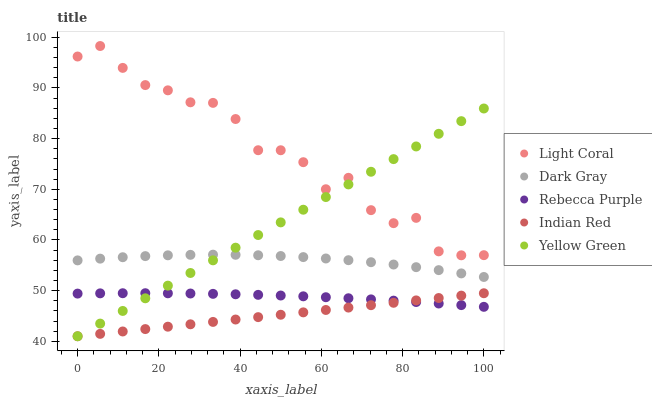Does Indian Red have the minimum area under the curve?
Answer yes or no. Yes. Does Light Coral have the maximum area under the curve?
Answer yes or no. Yes. Does Dark Gray have the minimum area under the curve?
Answer yes or no. No. Does Dark Gray have the maximum area under the curve?
Answer yes or no. No. Is Yellow Green the smoothest?
Answer yes or no. Yes. Is Light Coral the roughest?
Answer yes or no. Yes. Is Dark Gray the smoothest?
Answer yes or no. No. Is Dark Gray the roughest?
Answer yes or no. No. Does Indian Red have the lowest value?
Answer yes or no. Yes. Does Dark Gray have the lowest value?
Answer yes or no. No. Does Light Coral have the highest value?
Answer yes or no. Yes. Does Dark Gray have the highest value?
Answer yes or no. No. Is Dark Gray less than Light Coral?
Answer yes or no. Yes. Is Dark Gray greater than Rebecca Purple?
Answer yes or no. Yes. Does Yellow Green intersect Light Coral?
Answer yes or no. Yes. Is Yellow Green less than Light Coral?
Answer yes or no. No. Is Yellow Green greater than Light Coral?
Answer yes or no. No. Does Dark Gray intersect Light Coral?
Answer yes or no. No. 